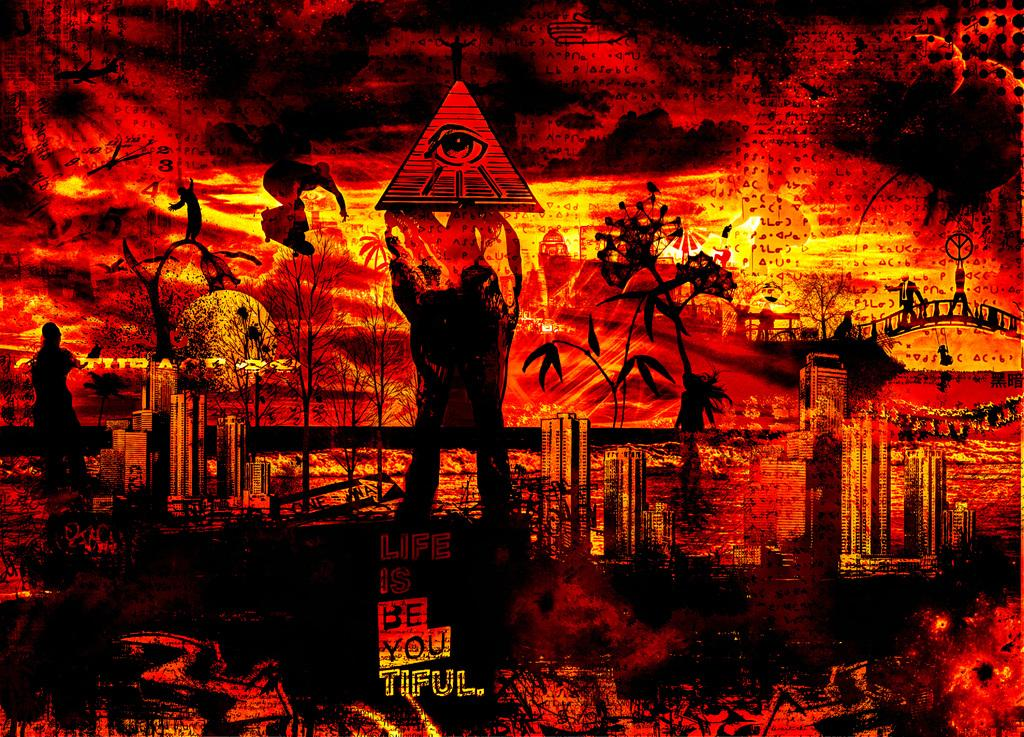<image>
Create a compact narrative representing the image presented. An illustration showing fire and devastation that contains a pun on life is beautiful by instead saying life is be-you-tiful. 